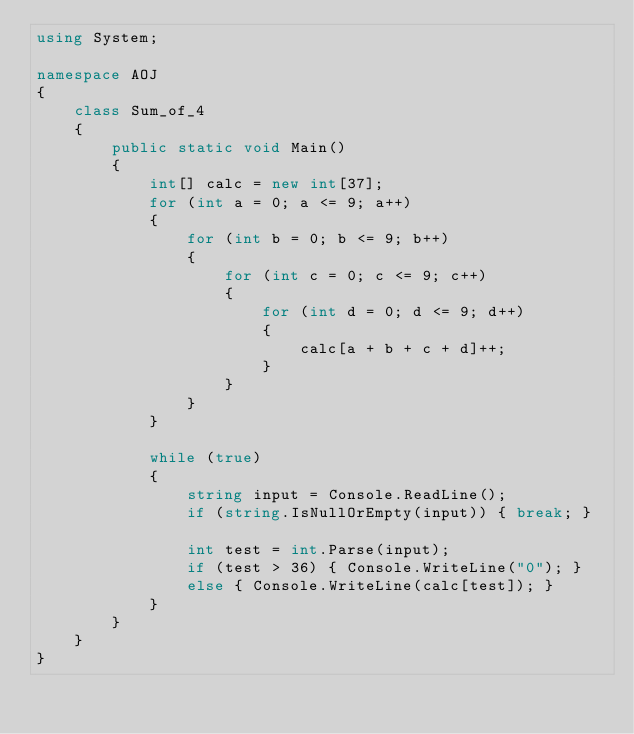<code> <loc_0><loc_0><loc_500><loc_500><_C#_>using System;

namespace AOJ
{
    class Sum_of_4
    {
        public static void Main()
        {
            int[] calc = new int[37];
            for (int a = 0; a <= 9; a++)
            {
                for (int b = 0; b <= 9; b++)
                {
                    for (int c = 0; c <= 9; c++)
                    {
                        for (int d = 0; d <= 9; d++)
                        {
                            calc[a + b + c + d]++;
                        }
                    }
                }
            }

            while (true)
            {
                string input = Console.ReadLine();
                if (string.IsNullOrEmpty(input)) { break; }

                int test = int.Parse(input);
                if (test > 36) { Console.WriteLine("0"); }
                else { Console.WriteLine(calc[test]); }
            }
        }
    }
}</code> 